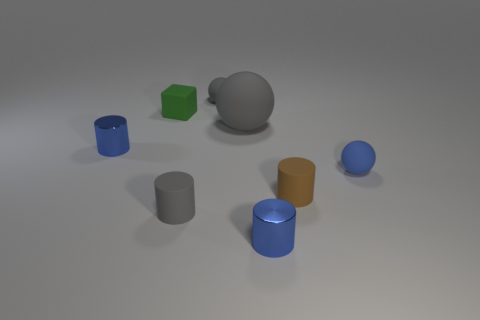Is there anything else that is the same color as the large object?
Your answer should be compact. Yes. There is a large object; is it the same color as the tiny sphere left of the tiny blue matte sphere?
Offer a terse response. Yes. There is a small blue metallic object to the left of the blue cylinder in front of the brown rubber cylinder; what is its shape?
Provide a succinct answer. Cylinder. There is another ball that is the same color as the big rubber sphere; what size is it?
Offer a terse response. Small. Does the shiny object that is on the right side of the gray cylinder have the same shape as the green thing?
Your response must be concise. No. Is the number of small metal cylinders on the right side of the tiny gray cylinder greater than the number of small green blocks that are right of the green cube?
Your answer should be compact. Yes. There is a small metallic cylinder that is in front of the small blue sphere; how many matte balls are left of it?
Your answer should be compact. 2. What is the material of the tiny cylinder that is the same color as the big thing?
Offer a terse response. Rubber. What number of other things are there of the same color as the rubber cube?
Give a very brief answer. 0. What is the color of the small sphere that is behind the blue cylinder that is left of the green rubber cube?
Keep it short and to the point. Gray. 